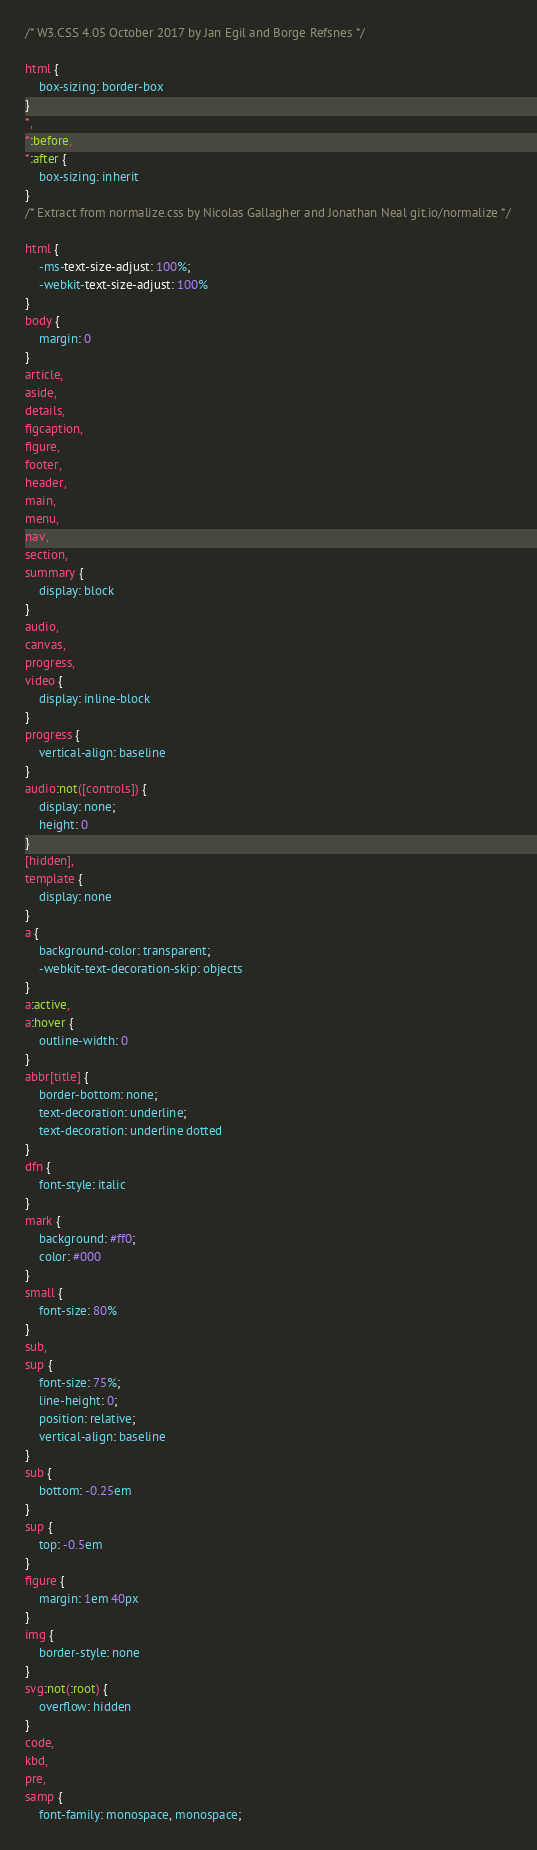Convert code to text. <code><loc_0><loc_0><loc_500><loc_500><_CSS_>/* W3.CSS 4.05 October 2017 by Jan Egil and Borge Refsnes */

html {
    box-sizing: border-box
}
*,
*:before,
*:after {
    box-sizing: inherit
}
/* Extract from normalize.css by Nicolas Gallagher and Jonathan Neal git.io/normalize */

html {
    -ms-text-size-adjust: 100%;
    -webkit-text-size-adjust: 100%
}
body {
    margin: 0
}
article,
aside,
details,
figcaption,
figure,
footer,
header,
main,
menu,
nav,
section,
summary {
    display: block
}
audio,
canvas,
progress,
video {
    display: inline-block
}
progress {
    vertical-align: baseline
}
audio:not([controls]) {
    display: none;
    height: 0
}
[hidden],
template {
    display: none
}
a {
    background-color: transparent;
    -webkit-text-decoration-skip: objects
}
a:active,
a:hover {
    outline-width: 0
}
abbr[title] {
    border-bottom: none;
    text-decoration: underline;
    text-decoration: underline dotted
}
dfn {
    font-style: italic
}
mark {
    background: #ff0;
    color: #000
}
small {
    font-size: 80%
}
sub,
sup {
    font-size: 75%;
    line-height: 0;
    position: relative;
    vertical-align: baseline
}
sub {
    bottom: -0.25em
}
sup {
    top: -0.5em
}
figure {
    margin: 1em 40px
}
img {
    border-style: none
}
svg:not(:root) {
    overflow: hidden
}
code,
kbd,
pre,
samp {
    font-family: monospace, monospace;</code> 